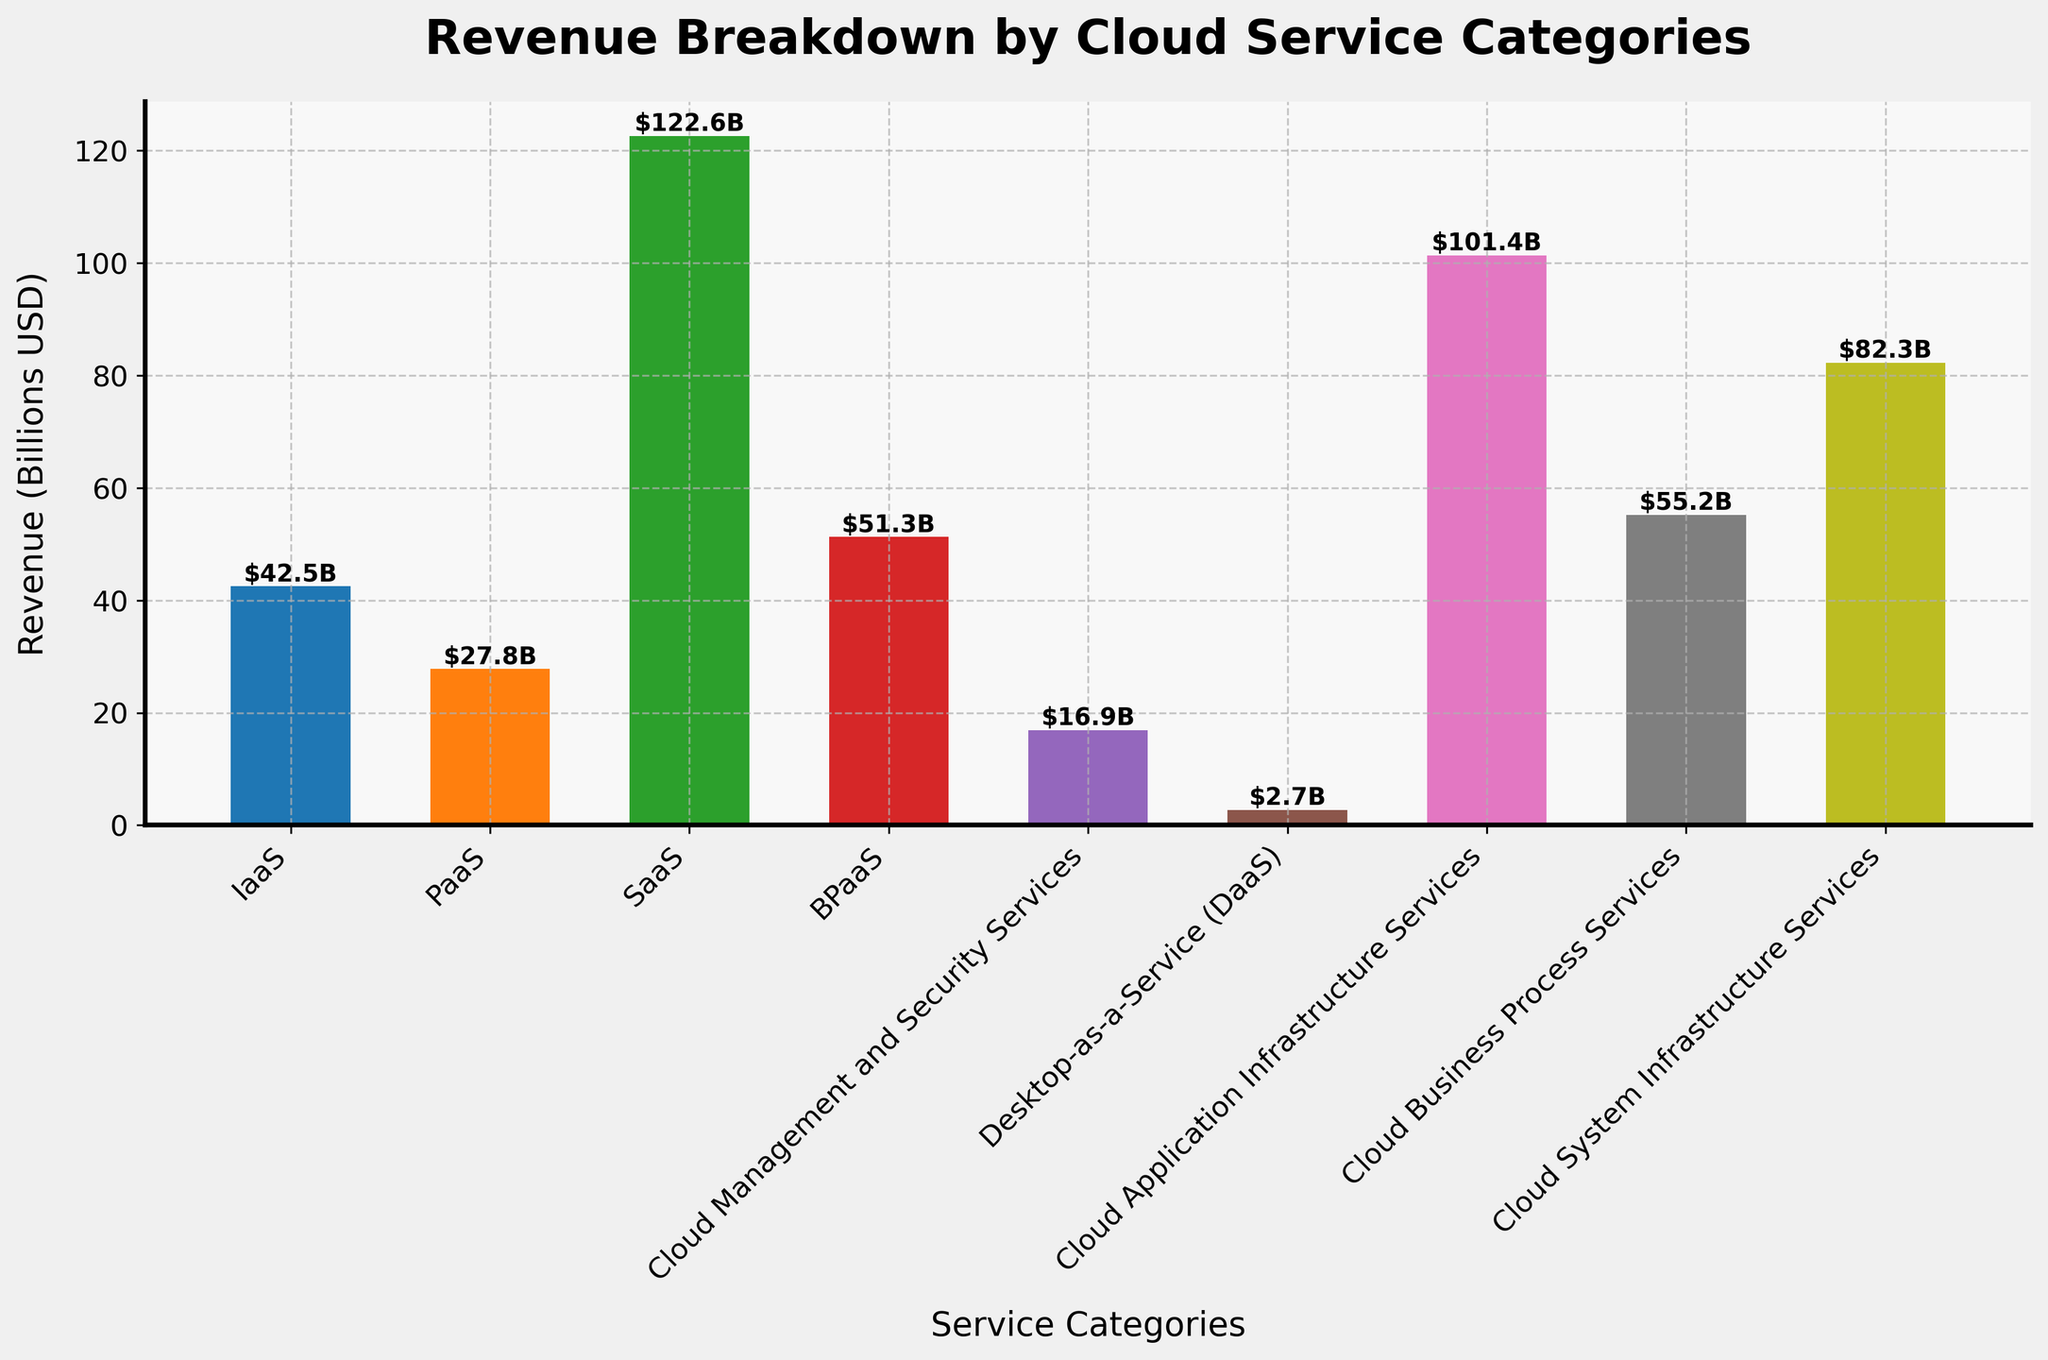What service category has the highest revenue? Look at the bar with the greatest height; this represents the service category with the highest revenue. The tallest bar represents SaaS with a value of 122.6 billion USD.
Answer: SaaS Which service category has the lowest revenue? Look at the bar with the smallest height; this represents the service category with the lowest revenue. The shortest bar represents Desktop-as-a-Service (DaaS) with a value of 2.7 billion USD.
Answer: Desktop-as-a-Service (DaaS) What is the combined revenue of BPaaS and Cloud Business Process Services? Find the values for BPaaS (51.3 billion USD) and Cloud Business Process Services (55.2 billion USD) and add them together: 51.3 + 55.2 = 106.5 billion USD.
Answer: 106.5 billion USD How much more revenue does SaaS generate compared to IaaS? Subtract the revenue of IaaS (42.5 billion USD) from SaaS (122.6 billion USD): 122.6 - 42.5 = 80.1 billion USD.
Answer: 80.1 billion USD What is the average revenue of Cloud Management and Security Services and Cloud System Infrastructure Services? Find the values for Cloud Management and Security Services (16.9 billion USD) and Cloud System Infrastructure Services (82.3 billion USD), add them, and then divide by 2: (16.9 + 82.3) / 2 = 49.6 billion USD.
Answer: 49.6 billion USD Which two cloud services have the closest revenue values? Compare the heights of the bars visually to find the two that are closest to each other. BPaaS (51.3 billion USD) and Cloud Business Process Services (55.2 billion USD) have close values.
Answer: BPaaS and Cloud Business Process Services What percentage of total revenue is contributed by SaaS? Calculate the total revenue by summing all categories, then divide SaaS revenue by total revenue and multiply by 100. Total Revenue = 501.7 billion USD. Percentage = (122.6 / 501.7) * 100 ≈ 24.4%.
Answer: 24.4% List the cloud services in descending order of revenue. Arrange the bars from tallest to shortest. The order is SaaS, Cloud Application Infrastructure Services, Cloud System Infrastructure Services, Cloud Business Process Services, BPaaS, IaaS, PaaS, Cloud Management and Security Services, and Desktop-as-a-Service.
Answer: SaaS, Cloud Application Infrastructure Services, Cloud System Infrastructure Services, Cloud Business Process Services, BPaaS, IaaS, PaaS, Cloud Management and Security Services, Desktop-as-a-Service What is the total revenue of all cloud services combined? Sum up all the individual revenues: 42.5 + 27.8 + 122.6 + 51.3 + 16.9 + 2.7 + 101.4 + 55.2 + 82.3 = 501.7 billion USD.
Answer: 501.7 billion USD How does the revenue of PaaS compare with Cloud Management and Security Services? Find the revenue values for PaaS (27.8 billion USD) and Cloud Management and Security Services (16.9 billion USD) and compare. PaaS generates more revenue than Cloud Management and Security Services.
Answer: PaaS generates more revenue 